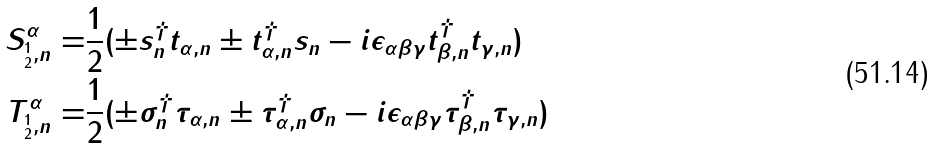<formula> <loc_0><loc_0><loc_500><loc_500>S _ { _ { 2 } ^ { 1 } , n } ^ { \alpha } = & \frac { 1 } { 2 } ( \pm s _ { n } ^ { \dagger } t _ { \alpha , n } \pm t _ { \alpha , n } ^ { \dagger } s _ { n } - i \epsilon _ { \alpha \beta \gamma } t _ { \beta , n } ^ { \dagger } t _ { \gamma , n } ) \\ T _ { _ { 2 } ^ { 1 } , n } ^ { \alpha } = & \frac { 1 } { 2 } ( \pm \sigma _ { n } ^ { \dagger } \tau _ { \alpha , n } \pm \tau _ { \alpha , n } ^ { \dagger } \sigma _ { n } - i \epsilon _ { \alpha \beta \gamma } \tau _ { \beta , n } ^ { \dagger } \tau _ { \gamma , n } )</formula> 